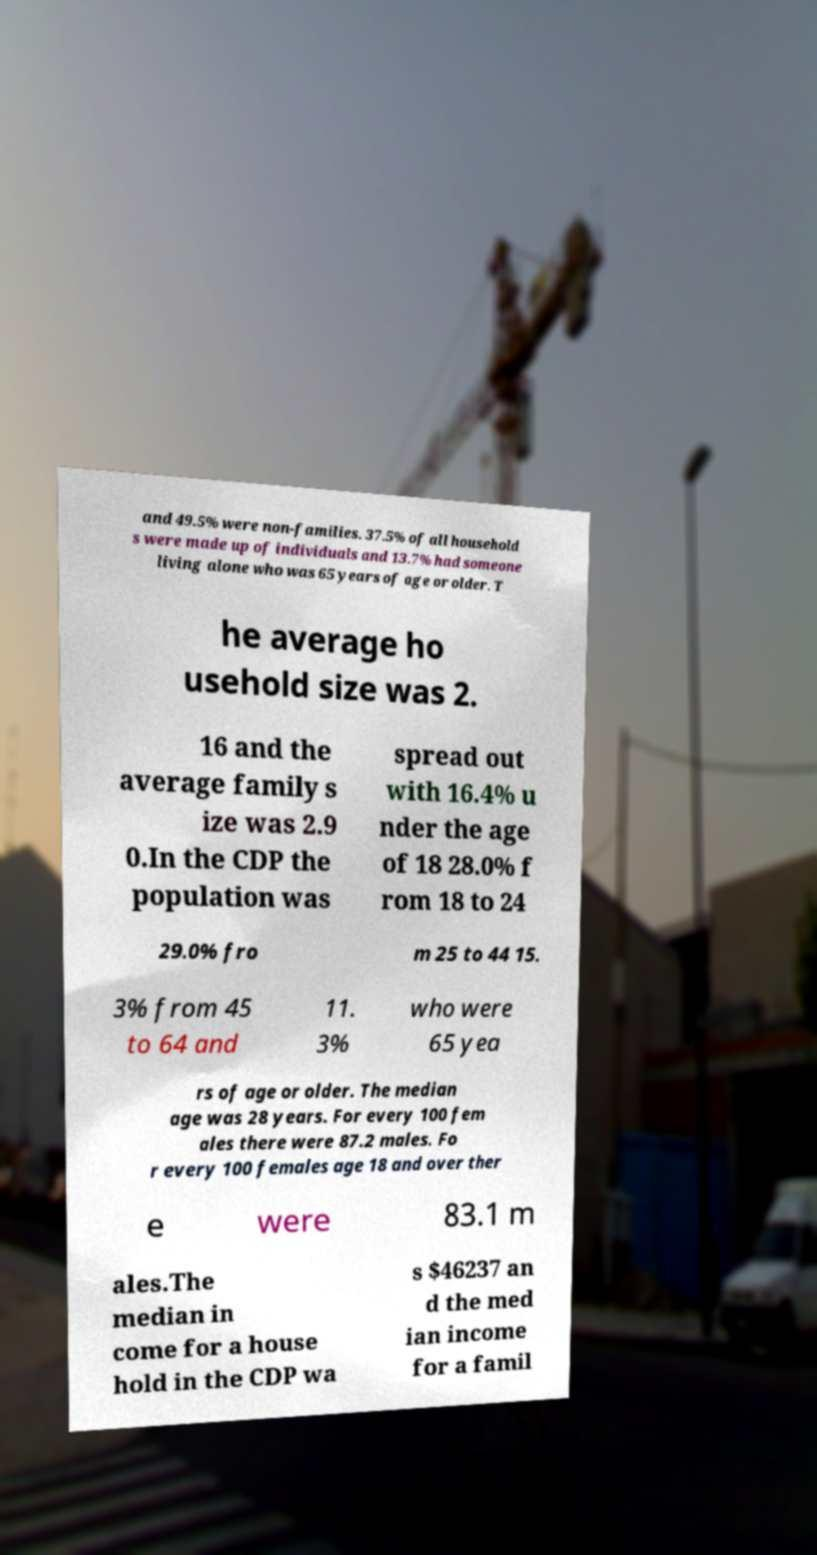There's text embedded in this image that I need extracted. Can you transcribe it verbatim? and 49.5% were non-families. 37.5% of all household s were made up of individuals and 13.7% had someone living alone who was 65 years of age or older. T he average ho usehold size was 2. 16 and the average family s ize was 2.9 0.In the CDP the population was spread out with 16.4% u nder the age of 18 28.0% f rom 18 to 24 29.0% fro m 25 to 44 15. 3% from 45 to 64 and 11. 3% who were 65 yea rs of age or older. The median age was 28 years. For every 100 fem ales there were 87.2 males. Fo r every 100 females age 18 and over ther e were 83.1 m ales.The median in come for a house hold in the CDP wa s $46237 an d the med ian income for a famil 